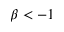<formula> <loc_0><loc_0><loc_500><loc_500>\beta < - 1</formula> 